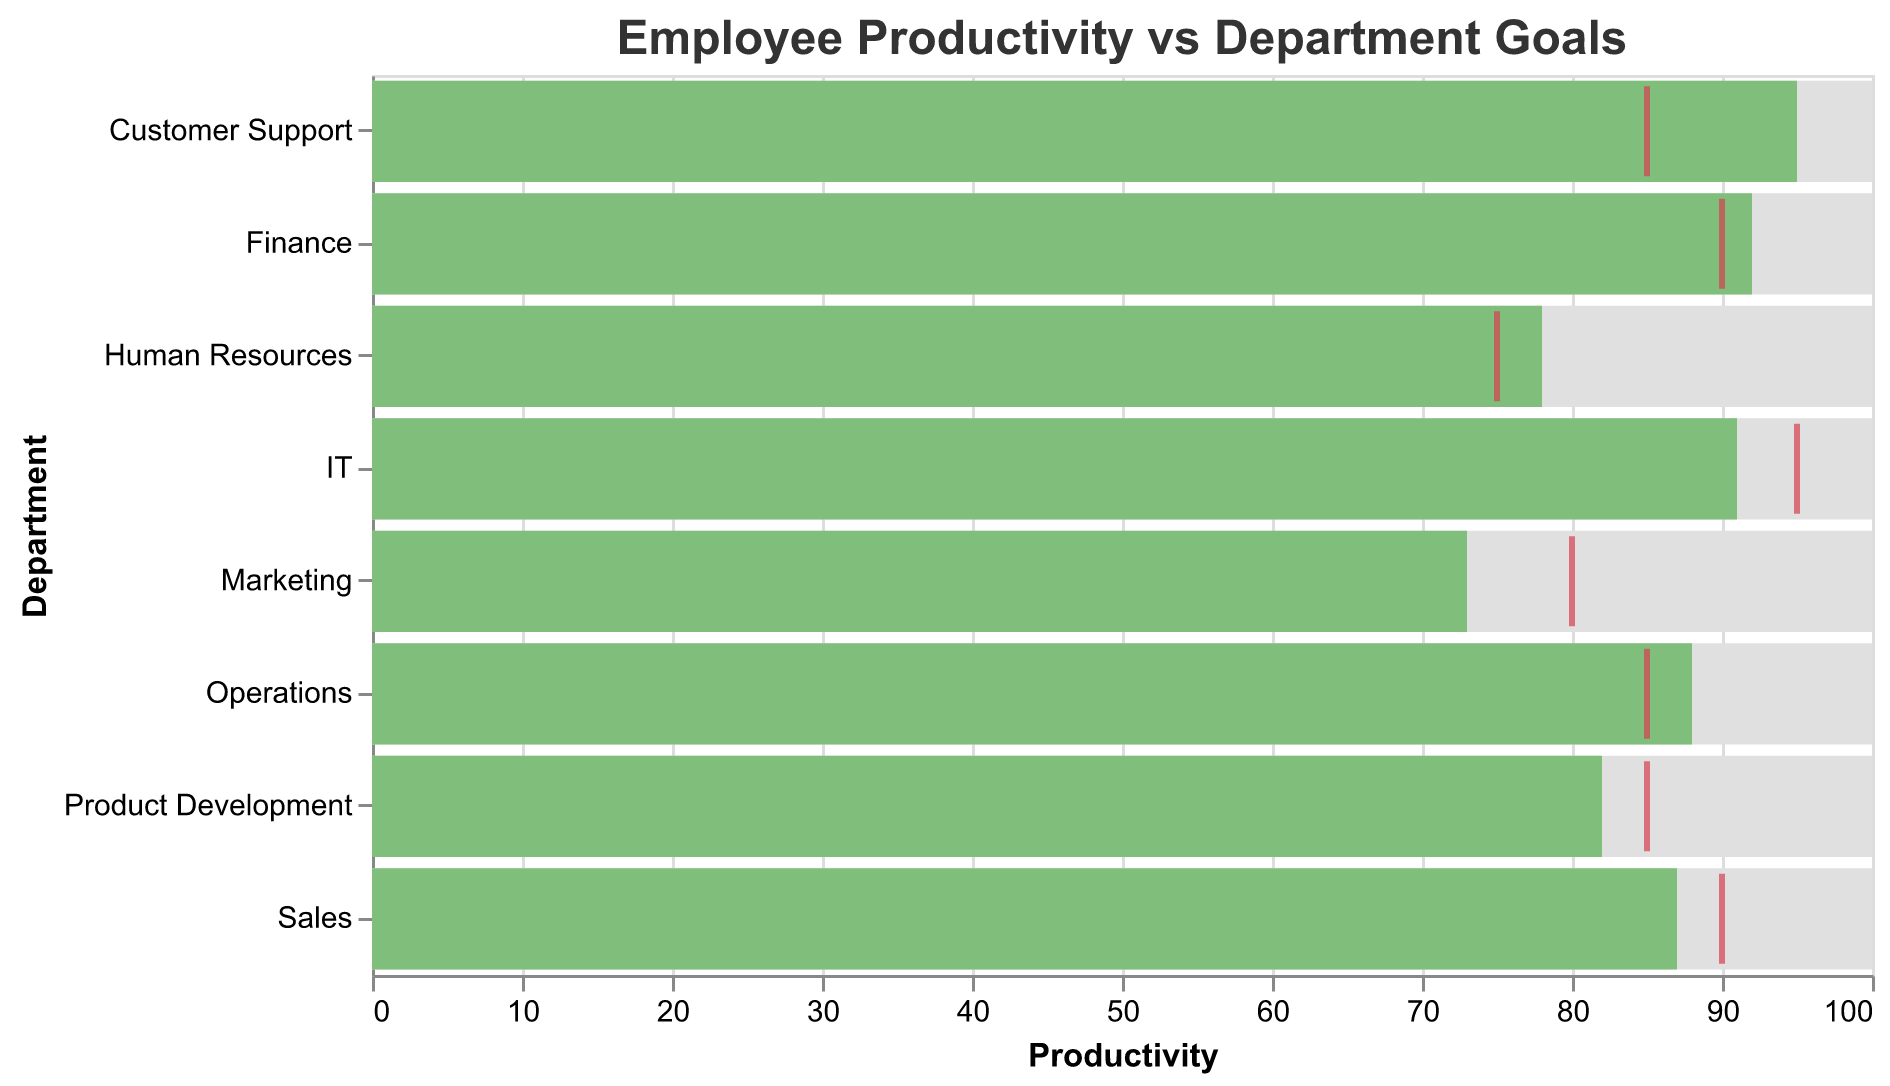What's the title of the chart? The title appears at the top of the chart and usually provides a brief description of what the chart represents. In this case, it is "Employee Productivity vs Department Goals."
Answer: Employee Productivity vs Department Goals What is the maximum productivity value represented on the chart? In a bullet chart, the maximum value is typically shown as a full-width bar. For this chart, the bars representing the maximum productivity values reach up to 100 for all departments.
Answer: 100 Which department has the highest actual productivity? By visually inspecting the chart, the "Customer Support" department has the highest actual productivity value, with a value of 95.
Answer: Customer Support Which department has the lowest actual productivity? According to the chart, the "Marketing" department has the lowest actual productivity value, which is 73.
Answer: Marketing For which departments did the actual productivity exceed the target? By comparing the actual productivity bars with the target ticks, we see that the departments "Customer Support," "Human Resources," "Finance," and "Operations" have actual productivity values exceeding their targets.
Answer: Customer Support, Human Resources, Finance, Operations How far is the IT department's actual productivity from its target? The IT department's actual productivity is 91, and its target is 95. The difference is calculated as 95 - 91 = 4.
Answer: 4 Which department has its actual productivity nearest to its target? By comparing the difference between the target and actual productivity values for each department, the "Sales" department has the smallest gap, with a target of 90 and an actual productivity of 87, making the difference 3.
Answer: Sales Compare the actual productivity values for Sales and Marketing departments. Which is higher and by how much? Sales has an actual productivity of 87, while Marketing has 73. The difference is calculated as 87 - 73 = 14. Therefore, Sales is higher by 14.
Answer: Sales, 14 Across all departments, what is the average target productivity value? The target values are 90, 80, 85, 85, 75, 90, 85, and 95. Summing these gives 685, and there are 8 departments. The average is 685 / 8 = 85.625.
Answer: 85.625 Which departments have their actual productivity values within 5 units of their targets? By checking each department's actual and target values, the departments "Sales" (87/90), "Product Development" (82/85), and "IT" (91/95) have differences that fall within 5 units.
Answer: Sales, Product Development, IT 